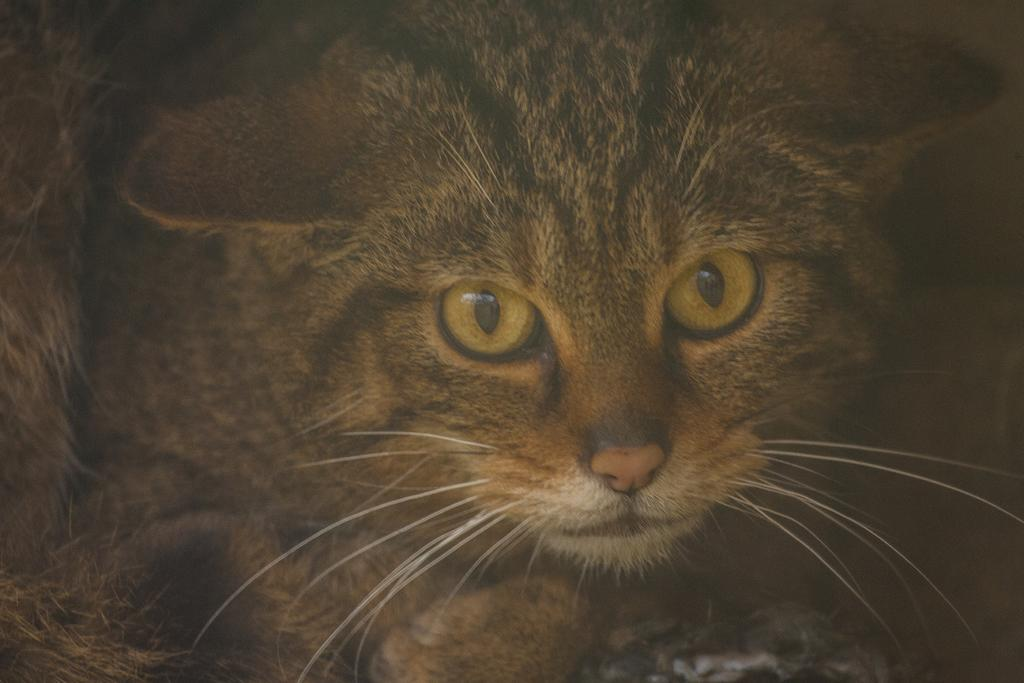What type of animal is in the image? There is a cat in the image. Can you describe the color pattern of the cat? The cat is black and brown in color. Where is the cat located in the image? The cat is not located in a zoo in the image; it is simply a cat in the image. What type of feather can be seen on the cat in the image? There is no feather present on the cat in the image. 